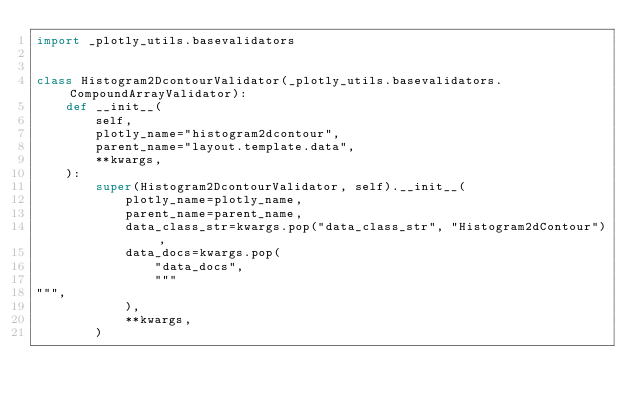Convert code to text. <code><loc_0><loc_0><loc_500><loc_500><_Python_>import _plotly_utils.basevalidators


class Histogram2DcontourValidator(_plotly_utils.basevalidators.CompoundArrayValidator):
    def __init__(
        self,
        plotly_name="histogram2dcontour",
        parent_name="layout.template.data",
        **kwargs,
    ):
        super(Histogram2DcontourValidator, self).__init__(
            plotly_name=plotly_name,
            parent_name=parent_name,
            data_class_str=kwargs.pop("data_class_str", "Histogram2dContour"),
            data_docs=kwargs.pop(
                "data_docs",
                """
""",
            ),
            **kwargs,
        )
</code> 